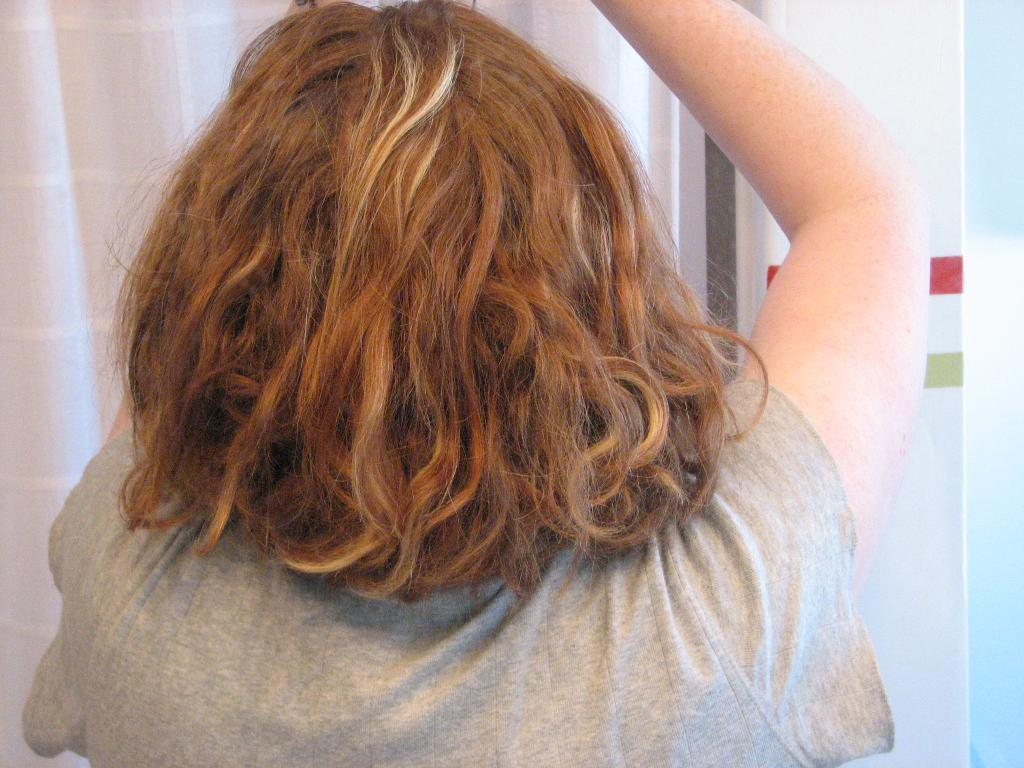Who or what is present in the image? There is a person in the image. What is visible behind the person in the image? There is a curtain behind the person in the image. What type of oil can be seen dripping from the person's hand in the image? There is no oil present in the image, nor is there any indication of dripping oil from the person's hand. 